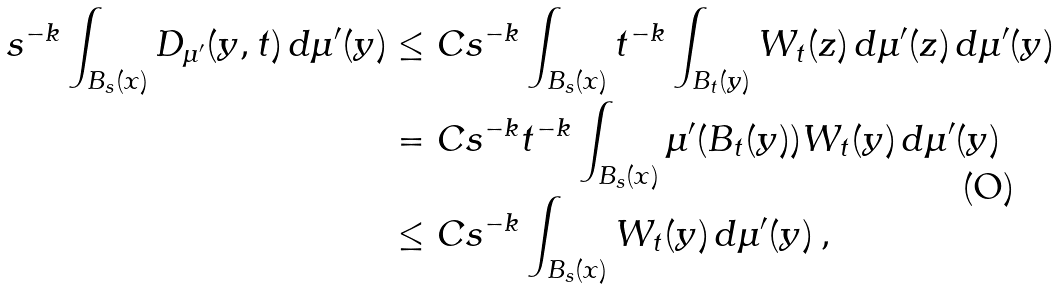<formula> <loc_0><loc_0><loc_500><loc_500>s ^ { - k } \int _ { B _ { s } ( x ) } D _ { \mu ^ { \prime } } ( y , t ) \, d \mu ^ { \prime } ( y ) & \leq C s ^ { - k } \int _ { B _ { s } ( x ) } t ^ { - k } \int _ { B _ { t } ( y ) } W _ { t } ( z ) \, d \mu ^ { \prime } ( z ) \, d \mu ^ { \prime } ( y ) \\ & = C s ^ { - k } t ^ { - k } \int _ { B _ { s } ( x ) } \mu ^ { \prime } ( B _ { t } ( y ) ) W _ { t } ( y ) \, d \mu ^ { \prime } ( y ) \\ & \leq C s ^ { - k } \int _ { B _ { s } ( x ) } W _ { t } ( y ) \, d \mu ^ { \prime } ( y ) \, ,</formula> 